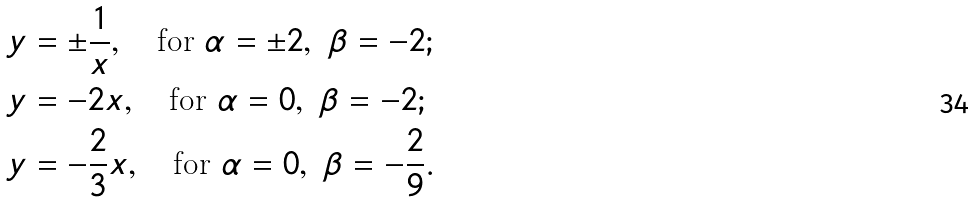<formula> <loc_0><loc_0><loc_500><loc_500>& y = \pm \frac { 1 } { x } , \quad \text {for} \ \alpha = \pm 2 , \ \beta = - 2 ; \\ & y = - 2 x , \quad \text {for} \ \alpha = 0 , \ \beta = - 2 ; \\ & y = - \frac { 2 } { 3 } x , \quad \text {for} \ \alpha = 0 , \ \beta = - \frac { 2 } { 9 } .</formula> 